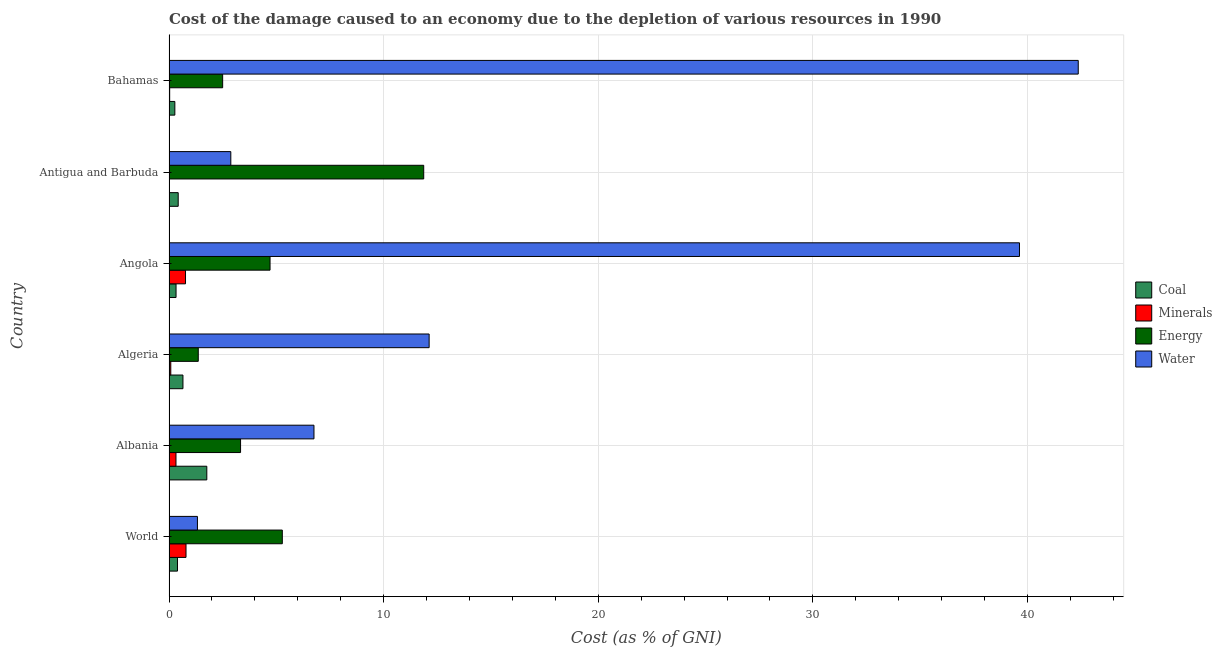How many different coloured bars are there?
Provide a short and direct response. 4. Are the number of bars per tick equal to the number of legend labels?
Keep it short and to the point. Yes. How many bars are there on the 5th tick from the bottom?
Provide a succinct answer. 4. What is the label of the 1st group of bars from the top?
Make the answer very short. Bahamas. In how many cases, is the number of bars for a given country not equal to the number of legend labels?
Give a very brief answer. 0. What is the cost of damage due to depletion of coal in World?
Make the answer very short. 0.4. Across all countries, what is the maximum cost of damage due to depletion of energy?
Offer a terse response. 11.87. Across all countries, what is the minimum cost of damage due to depletion of water?
Provide a succinct answer. 1.32. In which country was the cost of damage due to depletion of water minimum?
Offer a terse response. World. What is the total cost of damage due to depletion of water in the graph?
Offer a terse response. 105.07. What is the difference between the cost of damage due to depletion of energy in Albania and that in Bahamas?
Keep it short and to the point. 0.83. What is the difference between the cost of damage due to depletion of energy in Angola and the cost of damage due to depletion of minerals in Antigua and Barbuda?
Your answer should be very brief. 4.69. What is the average cost of damage due to depletion of coal per country?
Your answer should be compact. 0.64. What is the difference between the cost of damage due to depletion of coal and cost of damage due to depletion of energy in Bahamas?
Give a very brief answer. -2.23. In how many countries, is the cost of damage due to depletion of minerals greater than 40 %?
Your answer should be compact. 0. What is the ratio of the cost of damage due to depletion of coal in Albania to that in Algeria?
Your answer should be very brief. 2.71. Is the difference between the cost of damage due to depletion of coal in Albania and Bahamas greater than the difference between the cost of damage due to depletion of energy in Albania and Bahamas?
Offer a very short reply. Yes. What is the difference between the highest and the second highest cost of damage due to depletion of energy?
Keep it short and to the point. 6.59. What is the difference between the highest and the lowest cost of damage due to depletion of coal?
Make the answer very short. 1.49. In how many countries, is the cost of damage due to depletion of minerals greater than the average cost of damage due to depletion of minerals taken over all countries?
Provide a short and direct response. 2. Is it the case that in every country, the sum of the cost of damage due to depletion of coal and cost of damage due to depletion of water is greater than the sum of cost of damage due to depletion of energy and cost of damage due to depletion of minerals?
Make the answer very short. No. What does the 3rd bar from the top in World represents?
Ensure brevity in your answer.  Minerals. What does the 4th bar from the bottom in Algeria represents?
Ensure brevity in your answer.  Water. Is it the case that in every country, the sum of the cost of damage due to depletion of coal and cost of damage due to depletion of minerals is greater than the cost of damage due to depletion of energy?
Ensure brevity in your answer.  No. How many countries are there in the graph?
Give a very brief answer. 6. What is the difference between two consecutive major ticks on the X-axis?
Keep it short and to the point. 10. Does the graph contain any zero values?
Offer a very short reply. No. Does the graph contain grids?
Provide a short and direct response. Yes. How are the legend labels stacked?
Your response must be concise. Vertical. What is the title of the graph?
Keep it short and to the point. Cost of the damage caused to an economy due to the depletion of various resources in 1990 . Does "Miscellaneous expenses" appear as one of the legend labels in the graph?
Offer a terse response. No. What is the label or title of the X-axis?
Your answer should be very brief. Cost (as % of GNI). What is the label or title of the Y-axis?
Your answer should be very brief. Country. What is the Cost (as % of GNI) in Coal in World?
Provide a short and direct response. 0.4. What is the Cost (as % of GNI) in Minerals in World?
Ensure brevity in your answer.  0.79. What is the Cost (as % of GNI) in Energy in World?
Your response must be concise. 5.28. What is the Cost (as % of GNI) of Water in World?
Provide a succinct answer. 1.32. What is the Cost (as % of GNI) in Coal in Albania?
Offer a very short reply. 1.76. What is the Cost (as % of GNI) of Minerals in Albania?
Offer a terse response. 0.33. What is the Cost (as % of GNI) in Energy in Albania?
Give a very brief answer. 3.33. What is the Cost (as % of GNI) in Water in Albania?
Offer a terse response. 6.75. What is the Cost (as % of GNI) of Coal in Algeria?
Offer a very short reply. 0.65. What is the Cost (as % of GNI) in Minerals in Algeria?
Offer a very short reply. 0.08. What is the Cost (as % of GNI) in Energy in Algeria?
Provide a succinct answer. 1.36. What is the Cost (as % of GNI) in Water in Algeria?
Your answer should be very brief. 12.12. What is the Cost (as % of GNI) of Coal in Angola?
Offer a terse response. 0.33. What is the Cost (as % of GNI) in Minerals in Angola?
Make the answer very short. 0.77. What is the Cost (as % of GNI) of Energy in Angola?
Provide a short and direct response. 4.71. What is the Cost (as % of GNI) of Water in Angola?
Make the answer very short. 39.63. What is the Cost (as % of GNI) of Coal in Antigua and Barbuda?
Your answer should be compact. 0.43. What is the Cost (as % of GNI) in Minerals in Antigua and Barbuda?
Your response must be concise. 0.02. What is the Cost (as % of GNI) of Energy in Antigua and Barbuda?
Your answer should be compact. 11.87. What is the Cost (as % of GNI) of Water in Antigua and Barbuda?
Keep it short and to the point. 2.88. What is the Cost (as % of GNI) in Coal in Bahamas?
Keep it short and to the point. 0.27. What is the Cost (as % of GNI) of Minerals in Bahamas?
Offer a very short reply. 0.03. What is the Cost (as % of GNI) in Energy in Bahamas?
Your answer should be compact. 2.5. What is the Cost (as % of GNI) of Water in Bahamas?
Make the answer very short. 42.36. Across all countries, what is the maximum Cost (as % of GNI) of Coal?
Provide a succinct answer. 1.76. Across all countries, what is the maximum Cost (as % of GNI) in Minerals?
Your answer should be compact. 0.79. Across all countries, what is the maximum Cost (as % of GNI) in Energy?
Keep it short and to the point. 11.87. Across all countries, what is the maximum Cost (as % of GNI) in Water?
Offer a terse response. 42.36. Across all countries, what is the minimum Cost (as % of GNI) in Coal?
Your answer should be compact. 0.27. Across all countries, what is the minimum Cost (as % of GNI) of Minerals?
Your response must be concise. 0.02. Across all countries, what is the minimum Cost (as % of GNI) of Energy?
Give a very brief answer. 1.36. Across all countries, what is the minimum Cost (as % of GNI) of Water?
Provide a short and direct response. 1.32. What is the total Cost (as % of GNI) in Coal in the graph?
Ensure brevity in your answer.  3.84. What is the total Cost (as % of GNI) of Minerals in the graph?
Offer a very short reply. 2.02. What is the total Cost (as % of GNI) of Energy in the graph?
Your response must be concise. 29.05. What is the total Cost (as % of GNI) of Water in the graph?
Provide a short and direct response. 105.07. What is the difference between the Cost (as % of GNI) of Coal in World and that in Albania?
Make the answer very short. -1.37. What is the difference between the Cost (as % of GNI) of Minerals in World and that in Albania?
Keep it short and to the point. 0.47. What is the difference between the Cost (as % of GNI) of Energy in World and that in Albania?
Provide a succinct answer. 1.94. What is the difference between the Cost (as % of GNI) in Water in World and that in Albania?
Make the answer very short. -5.43. What is the difference between the Cost (as % of GNI) in Coal in World and that in Algeria?
Your answer should be compact. -0.26. What is the difference between the Cost (as % of GNI) in Minerals in World and that in Algeria?
Your answer should be very brief. 0.71. What is the difference between the Cost (as % of GNI) of Energy in World and that in Algeria?
Give a very brief answer. 3.92. What is the difference between the Cost (as % of GNI) in Water in World and that in Algeria?
Offer a terse response. -10.8. What is the difference between the Cost (as % of GNI) in Coal in World and that in Angola?
Your response must be concise. 0.07. What is the difference between the Cost (as % of GNI) of Minerals in World and that in Angola?
Your answer should be very brief. 0.02. What is the difference between the Cost (as % of GNI) in Energy in World and that in Angola?
Offer a very short reply. 0.57. What is the difference between the Cost (as % of GNI) in Water in World and that in Angola?
Ensure brevity in your answer.  -38.3. What is the difference between the Cost (as % of GNI) in Coal in World and that in Antigua and Barbuda?
Ensure brevity in your answer.  -0.03. What is the difference between the Cost (as % of GNI) in Minerals in World and that in Antigua and Barbuda?
Provide a succinct answer. 0.77. What is the difference between the Cost (as % of GNI) of Energy in World and that in Antigua and Barbuda?
Your response must be concise. -6.59. What is the difference between the Cost (as % of GNI) in Water in World and that in Antigua and Barbuda?
Your answer should be compact. -1.56. What is the difference between the Cost (as % of GNI) of Coal in World and that in Bahamas?
Ensure brevity in your answer.  0.12. What is the difference between the Cost (as % of GNI) in Minerals in World and that in Bahamas?
Keep it short and to the point. 0.76. What is the difference between the Cost (as % of GNI) in Energy in World and that in Bahamas?
Offer a very short reply. 2.78. What is the difference between the Cost (as % of GNI) of Water in World and that in Bahamas?
Provide a succinct answer. -41.04. What is the difference between the Cost (as % of GNI) of Coal in Albania and that in Algeria?
Keep it short and to the point. 1.11. What is the difference between the Cost (as % of GNI) in Minerals in Albania and that in Algeria?
Give a very brief answer. 0.24. What is the difference between the Cost (as % of GNI) of Energy in Albania and that in Algeria?
Ensure brevity in your answer.  1.97. What is the difference between the Cost (as % of GNI) in Water in Albania and that in Algeria?
Your answer should be compact. -5.37. What is the difference between the Cost (as % of GNI) of Coal in Albania and that in Angola?
Make the answer very short. 1.43. What is the difference between the Cost (as % of GNI) of Minerals in Albania and that in Angola?
Your answer should be compact. -0.44. What is the difference between the Cost (as % of GNI) of Energy in Albania and that in Angola?
Give a very brief answer. -1.37. What is the difference between the Cost (as % of GNI) in Water in Albania and that in Angola?
Your answer should be compact. -32.87. What is the difference between the Cost (as % of GNI) of Coal in Albania and that in Antigua and Barbuda?
Offer a very short reply. 1.33. What is the difference between the Cost (as % of GNI) of Minerals in Albania and that in Antigua and Barbuda?
Give a very brief answer. 0.3. What is the difference between the Cost (as % of GNI) of Energy in Albania and that in Antigua and Barbuda?
Your answer should be very brief. -8.53. What is the difference between the Cost (as % of GNI) in Water in Albania and that in Antigua and Barbuda?
Offer a very short reply. 3.87. What is the difference between the Cost (as % of GNI) in Coal in Albania and that in Bahamas?
Make the answer very short. 1.49. What is the difference between the Cost (as % of GNI) of Minerals in Albania and that in Bahamas?
Provide a succinct answer. 0.29. What is the difference between the Cost (as % of GNI) of Energy in Albania and that in Bahamas?
Provide a short and direct response. 0.83. What is the difference between the Cost (as % of GNI) of Water in Albania and that in Bahamas?
Keep it short and to the point. -35.61. What is the difference between the Cost (as % of GNI) in Coal in Algeria and that in Angola?
Make the answer very short. 0.32. What is the difference between the Cost (as % of GNI) in Minerals in Algeria and that in Angola?
Your response must be concise. -0.69. What is the difference between the Cost (as % of GNI) in Energy in Algeria and that in Angola?
Your answer should be compact. -3.34. What is the difference between the Cost (as % of GNI) of Water in Algeria and that in Angola?
Ensure brevity in your answer.  -27.51. What is the difference between the Cost (as % of GNI) in Coal in Algeria and that in Antigua and Barbuda?
Keep it short and to the point. 0.22. What is the difference between the Cost (as % of GNI) of Minerals in Algeria and that in Antigua and Barbuda?
Give a very brief answer. 0.06. What is the difference between the Cost (as % of GNI) in Energy in Algeria and that in Antigua and Barbuda?
Your answer should be compact. -10.5. What is the difference between the Cost (as % of GNI) in Water in Algeria and that in Antigua and Barbuda?
Provide a short and direct response. 9.24. What is the difference between the Cost (as % of GNI) in Coal in Algeria and that in Bahamas?
Make the answer very short. 0.38. What is the difference between the Cost (as % of GNI) of Minerals in Algeria and that in Bahamas?
Ensure brevity in your answer.  0.05. What is the difference between the Cost (as % of GNI) of Energy in Algeria and that in Bahamas?
Give a very brief answer. -1.14. What is the difference between the Cost (as % of GNI) in Water in Algeria and that in Bahamas?
Give a very brief answer. -30.24. What is the difference between the Cost (as % of GNI) of Coal in Angola and that in Antigua and Barbuda?
Provide a short and direct response. -0.1. What is the difference between the Cost (as % of GNI) in Minerals in Angola and that in Antigua and Barbuda?
Your answer should be very brief. 0.75. What is the difference between the Cost (as % of GNI) of Energy in Angola and that in Antigua and Barbuda?
Offer a very short reply. -7.16. What is the difference between the Cost (as % of GNI) of Water in Angola and that in Antigua and Barbuda?
Your answer should be compact. 36.75. What is the difference between the Cost (as % of GNI) of Coal in Angola and that in Bahamas?
Your response must be concise. 0.06. What is the difference between the Cost (as % of GNI) of Minerals in Angola and that in Bahamas?
Offer a very short reply. 0.74. What is the difference between the Cost (as % of GNI) of Energy in Angola and that in Bahamas?
Your response must be concise. 2.21. What is the difference between the Cost (as % of GNI) of Water in Angola and that in Bahamas?
Make the answer very short. -2.74. What is the difference between the Cost (as % of GNI) of Coal in Antigua and Barbuda and that in Bahamas?
Make the answer very short. 0.16. What is the difference between the Cost (as % of GNI) in Minerals in Antigua and Barbuda and that in Bahamas?
Ensure brevity in your answer.  -0.01. What is the difference between the Cost (as % of GNI) of Energy in Antigua and Barbuda and that in Bahamas?
Your response must be concise. 9.37. What is the difference between the Cost (as % of GNI) of Water in Antigua and Barbuda and that in Bahamas?
Make the answer very short. -39.48. What is the difference between the Cost (as % of GNI) of Coal in World and the Cost (as % of GNI) of Minerals in Albania?
Give a very brief answer. 0.07. What is the difference between the Cost (as % of GNI) in Coal in World and the Cost (as % of GNI) in Energy in Albania?
Make the answer very short. -2.94. What is the difference between the Cost (as % of GNI) in Coal in World and the Cost (as % of GNI) in Water in Albania?
Your response must be concise. -6.36. What is the difference between the Cost (as % of GNI) of Minerals in World and the Cost (as % of GNI) of Energy in Albania?
Your answer should be very brief. -2.54. What is the difference between the Cost (as % of GNI) in Minerals in World and the Cost (as % of GNI) in Water in Albania?
Your answer should be compact. -5.96. What is the difference between the Cost (as % of GNI) of Energy in World and the Cost (as % of GNI) of Water in Albania?
Give a very brief answer. -1.47. What is the difference between the Cost (as % of GNI) of Coal in World and the Cost (as % of GNI) of Minerals in Algeria?
Your answer should be very brief. 0.31. What is the difference between the Cost (as % of GNI) in Coal in World and the Cost (as % of GNI) in Energy in Algeria?
Your answer should be compact. -0.97. What is the difference between the Cost (as % of GNI) of Coal in World and the Cost (as % of GNI) of Water in Algeria?
Your answer should be compact. -11.73. What is the difference between the Cost (as % of GNI) of Minerals in World and the Cost (as % of GNI) of Energy in Algeria?
Ensure brevity in your answer.  -0.57. What is the difference between the Cost (as % of GNI) of Minerals in World and the Cost (as % of GNI) of Water in Algeria?
Your answer should be very brief. -11.33. What is the difference between the Cost (as % of GNI) in Energy in World and the Cost (as % of GNI) in Water in Algeria?
Your answer should be compact. -6.84. What is the difference between the Cost (as % of GNI) of Coal in World and the Cost (as % of GNI) of Minerals in Angola?
Make the answer very short. -0.37. What is the difference between the Cost (as % of GNI) of Coal in World and the Cost (as % of GNI) of Energy in Angola?
Your answer should be very brief. -4.31. What is the difference between the Cost (as % of GNI) of Coal in World and the Cost (as % of GNI) of Water in Angola?
Give a very brief answer. -39.23. What is the difference between the Cost (as % of GNI) in Minerals in World and the Cost (as % of GNI) in Energy in Angola?
Your response must be concise. -3.92. What is the difference between the Cost (as % of GNI) in Minerals in World and the Cost (as % of GNI) in Water in Angola?
Ensure brevity in your answer.  -38.83. What is the difference between the Cost (as % of GNI) of Energy in World and the Cost (as % of GNI) of Water in Angola?
Provide a short and direct response. -34.35. What is the difference between the Cost (as % of GNI) in Coal in World and the Cost (as % of GNI) in Minerals in Antigua and Barbuda?
Make the answer very short. 0.37. What is the difference between the Cost (as % of GNI) in Coal in World and the Cost (as % of GNI) in Energy in Antigua and Barbuda?
Keep it short and to the point. -11.47. What is the difference between the Cost (as % of GNI) of Coal in World and the Cost (as % of GNI) of Water in Antigua and Barbuda?
Make the answer very short. -2.49. What is the difference between the Cost (as % of GNI) of Minerals in World and the Cost (as % of GNI) of Energy in Antigua and Barbuda?
Keep it short and to the point. -11.08. What is the difference between the Cost (as % of GNI) in Minerals in World and the Cost (as % of GNI) in Water in Antigua and Barbuda?
Your answer should be compact. -2.09. What is the difference between the Cost (as % of GNI) in Energy in World and the Cost (as % of GNI) in Water in Antigua and Barbuda?
Your answer should be compact. 2.4. What is the difference between the Cost (as % of GNI) in Coal in World and the Cost (as % of GNI) in Minerals in Bahamas?
Keep it short and to the point. 0.36. What is the difference between the Cost (as % of GNI) of Coal in World and the Cost (as % of GNI) of Energy in Bahamas?
Give a very brief answer. -2.1. What is the difference between the Cost (as % of GNI) of Coal in World and the Cost (as % of GNI) of Water in Bahamas?
Offer a terse response. -41.97. What is the difference between the Cost (as % of GNI) in Minerals in World and the Cost (as % of GNI) in Energy in Bahamas?
Ensure brevity in your answer.  -1.71. What is the difference between the Cost (as % of GNI) in Minerals in World and the Cost (as % of GNI) in Water in Bahamas?
Provide a succinct answer. -41.57. What is the difference between the Cost (as % of GNI) of Energy in World and the Cost (as % of GNI) of Water in Bahamas?
Provide a succinct answer. -37.09. What is the difference between the Cost (as % of GNI) in Coal in Albania and the Cost (as % of GNI) in Minerals in Algeria?
Your response must be concise. 1.68. What is the difference between the Cost (as % of GNI) of Coal in Albania and the Cost (as % of GNI) of Energy in Algeria?
Your response must be concise. 0.4. What is the difference between the Cost (as % of GNI) in Coal in Albania and the Cost (as % of GNI) in Water in Algeria?
Provide a succinct answer. -10.36. What is the difference between the Cost (as % of GNI) of Minerals in Albania and the Cost (as % of GNI) of Energy in Algeria?
Provide a short and direct response. -1.04. What is the difference between the Cost (as % of GNI) of Minerals in Albania and the Cost (as % of GNI) of Water in Algeria?
Offer a terse response. -11.79. What is the difference between the Cost (as % of GNI) in Energy in Albania and the Cost (as % of GNI) in Water in Algeria?
Ensure brevity in your answer.  -8.79. What is the difference between the Cost (as % of GNI) of Coal in Albania and the Cost (as % of GNI) of Minerals in Angola?
Offer a very short reply. 0.99. What is the difference between the Cost (as % of GNI) in Coal in Albania and the Cost (as % of GNI) in Energy in Angola?
Ensure brevity in your answer.  -2.95. What is the difference between the Cost (as % of GNI) in Coal in Albania and the Cost (as % of GNI) in Water in Angola?
Provide a short and direct response. -37.86. What is the difference between the Cost (as % of GNI) in Minerals in Albania and the Cost (as % of GNI) in Energy in Angola?
Your response must be concise. -4.38. What is the difference between the Cost (as % of GNI) of Minerals in Albania and the Cost (as % of GNI) of Water in Angola?
Your answer should be very brief. -39.3. What is the difference between the Cost (as % of GNI) in Energy in Albania and the Cost (as % of GNI) in Water in Angola?
Your response must be concise. -36.29. What is the difference between the Cost (as % of GNI) in Coal in Albania and the Cost (as % of GNI) in Minerals in Antigua and Barbuda?
Give a very brief answer. 1.74. What is the difference between the Cost (as % of GNI) of Coal in Albania and the Cost (as % of GNI) of Energy in Antigua and Barbuda?
Keep it short and to the point. -10.11. What is the difference between the Cost (as % of GNI) of Coal in Albania and the Cost (as % of GNI) of Water in Antigua and Barbuda?
Ensure brevity in your answer.  -1.12. What is the difference between the Cost (as % of GNI) in Minerals in Albania and the Cost (as % of GNI) in Energy in Antigua and Barbuda?
Your response must be concise. -11.54. What is the difference between the Cost (as % of GNI) of Minerals in Albania and the Cost (as % of GNI) of Water in Antigua and Barbuda?
Your response must be concise. -2.55. What is the difference between the Cost (as % of GNI) in Energy in Albania and the Cost (as % of GNI) in Water in Antigua and Barbuda?
Provide a succinct answer. 0.45. What is the difference between the Cost (as % of GNI) of Coal in Albania and the Cost (as % of GNI) of Minerals in Bahamas?
Give a very brief answer. 1.73. What is the difference between the Cost (as % of GNI) in Coal in Albania and the Cost (as % of GNI) in Energy in Bahamas?
Your response must be concise. -0.74. What is the difference between the Cost (as % of GNI) in Coal in Albania and the Cost (as % of GNI) in Water in Bahamas?
Provide a short and direct response. -40.6. What is the difference between the Cost (as % of GNI) of Minerals in Albania and the Cost (as % of GNI) of Energy in Bahamas?
Your answer should be very brief. -2.17. What is the difference between the Cost (as % of GNI) in Minerals in Albania and the Cost (as % of GNI) in Water in Bahamas?
Make the answer very short. -42.04. What is the difference between the Cost (as % of GNI) in Energy in Albania and the Cost (as % of GNI) in Water in Bahamas?
Offer a terse response. -39.03. What is the difference between the Cost (as % of GNI) in Coal in Algeria and the Cost (as % of GNI) in Minerals in Angola?
Your answer should be compact. -0.12. What is the difference between the Cost (as % of GNI) of Coal in Algeria and the Cost (as % of GNI) of Energy in Angola?
Offer a very short reply. -4.06. What is the difference between the Cost (as % of GNI) in Coal in Algeria and the Cost (as % of GNI) in Water in Angola?
Your answer should be compact. -38.98. What is the difference between the Cost (as % of GNI) of Minerals in Algeria and the Cost (as % of GNI) of Energy in Angola?
Provide a short and direct response. -4.63. What is the difference between the Cost (as % of GNI) of Minerals in Algeria and the Cost (as % of GNI) of Water in Angola?
Your answer should be very brief. -39.54. What is the difference between the Cost (as % of GNI) of Energy in Algeria and the Cost (as % of GNI) of Water in Angola?
Offer a very short reply. -38.26. What is the difference between the Cost (as % of GNI) in Coal in Algeria and the Cost (as % of GNI) in Minerals in Antigua and Barbuda?
Keep it short and to the point. 0.63. What is the difference between the Cost (as % of GNI) of Coal in Algeria and the Cost (as % of GNI) of Energy in Antigua and Barbuda?
Your answer should be compact. -11.22. What is the difference between the Cost (as % of GNI) in Coal in Algeria and the Cost (as % of GNI) in Water in Antigua and Barbuda?
Your answer should be very brief. -2.23. What is the difference between the Cost (as % of GNI) in Minerals in Algeria and the Cost (as % of GNI) in Energy in Antigua and Barbuda?
Ensure brevity in your answer.  -11.79. What is the difference between the Cost (as % of GNI) in Minerals in Algeria and the Cost (as % of GNI) in Water in Antigua and Barbuda?
Offer a very short reply. -2.8. What is the difference between the Cost (as % of GNI) in Energy in Algeria and the Cost (as % of GNI) in Water in Antigua and Barbuda?
Provide a succinct answer. -1.52. What is the difference between the Cost (as % of GNI) in Coal in Algeria and the Cost (as % of GNI) in Minerals in Bahamas?
Offer a terse response. 0.62. What is the difference between the Cost (as % of GNI) of Coal in Algeria and the Cost (as % of GNI) of Energy in Bahamas?
Make the answer very short. -1.85. What is the difference between the Cost (as % of GNI) of Coal in Algeria and the Cost (as % of GNI) of Water in Bahamas?
Your answer should be very brief. -41.71. What is the difference between the Cost (as % of GNI) in Minerals in Algeria and the Cost (as % of GNI) in Energy in Bahamas?
Keep it short and to the point. -2.42. What is the difference between the Cost (as % of GNI) in Minerals in Algeria and the Cost (as % of GNI) in Water in Bahamas?
Provide a short and direct response. -42.28. What is the difference between the Cost (as % of GNI) in Energy in Algeria and the Cost (as % of GNI) in Water in Bahamas?
Provide a short and direct response. -41. What is the difference between the Cost (as % of GNI) in Coal in Angola and the Cost (as % of GNI) in Minerals in Antigua and Barbuda?
Give a very brief answer. 0.31. What is the difference between the Cost (as % of GNI) in Coal in Angola and the Cost (as % of GNI) in Energy in Antigua and Barbuda?
Provide a succinct answer. -11.54. What is the difference between the Cost (as % of GNI) of Coal in Angola and the Cost (as % of GNI) of Water in Antigua and Barbuda?
Provide a succinct answer. -2.55. What is the difference between the Cost (as % of GNI) of Minerals in Angola and the Cost (as % of GNI) of Energy in Antigua and Barbuda?
Give a very brief answer. -11.1. What is the difference between the Cost (as % of GNI) in Minerals in Angola and the Cost (as % of GNI) in Water in Antigua and Barbuda?
Your answer should be compact. -2.11. What is the difference between the Cost (as % of GNI) in Energy in Angola and the Cost (as % of GNI) in Water in Antigua and Barbuda?
Ensure brevity in your answer.  1.83. What is the difference between the Cost (as % of GNI) of Coal in Angola and the Cost (as % of GNI) of Minerals in Bahamas?
Make the answer very short. 0.3. What is the difference between the Cost (as % of GNI) in Coal in Angola and the Cost (as % of GNI) in Energy in Bahamas?
Your response must be concise. -2.17. What is the difference between the Cost (as % of GNI) in Coal in Angola and the Cost (as % of GNI) in Water in Bahamas?
Give a very brief answer. -42.04. What is the difference between the Cost (as % of GNI) in Minerals in Angola and the Cost (as % of GNI) in Energy in Bahamas?
Your response must be concise. -1.73. What is the difference between the Cost (as % of GNI) of Minerals in Angola and the Cost (as % of GNI) of Water in Bahamas?
Your answer should be very brief. -41.6. What is the difference between the Cost (as % of GNI) of Energy in Angola and the Cost (as % of GNI) of Water in Bahamas?
Provide a short and direct response. -37.66. What is the difference between the Cost (as % of GNI) of Coal in Antigua and Barbuda and the Cost (as % of GNI) of Minerals in Bahamas?
Make the answer very short. 0.4. What is the difference between the Cost (as % of GNI) of Coal in Antigua and Barbuda and the Cost (as % of GNI) of Energy in Bahamas?
Ensure brevity in your answer.  -2.07. What is the difference between the Cost (as % of GNI) in Coal in Antigua and Barbuda and the Cost (as % of GNI) in Water in Bahamas?
Ensure brevity in your answer.  -41.94. What is the difference between the Cost (as % of GNI) of Minerals in Antigua and Barbuda and the Cost (as % of GNI) of Energy in Bahamas?
Ensure brevity in your answer.  -2.48. What is the difference between the Cost (as % of GNI) in Minerals in Antigua and Barbuda and the Cost (as % of GNI) in Water in Bahamas?
Provide a succinct answer. -42.34. What is the difference between the Cost (as % of GNI) in Energy in Antigua and Barbuda and the Cost (as % of GNI) in Water in Bahamas?
Offer a very short reply. -30.5. What is the average Cost (as % of GNI) in Coal per country?
Your answer should be very brief. 0.64. What is the average Cost (as % of GNI) in Minerals per country?
Offer a very short reply. 0.34. What is the average Cost (as % of GNI) in Energy per country?
Your response must be concise. 4.84. What is the average Cost (as % of GNI) of Water per country?
Provide a short and direct response. 17.51. What is the difference between the Cost (as % of GNI) of Coal and Cost (as % of GNI) of Minerals in World?
Make the answer very short. -0.4. What is the difference between the Cost (as % of GNI) in Coal and Cost (as % of GNI) in Energy in World?
Keep it short and to the point. -4.88. What is the difference between the Cost (as % of GNI) in Coal and Cost (as % of GNI) in Water in World?
Provide a succinct answer. -0.93. What is the difference between the Cost (as % of GNI) in Minerals and Cost (as % of GNI) in Energy in World?
Your response must be concise. -4.49. What is the difference between the Cost (as % of GNI) in Minerals and Cost (as % of GNI) in Water in World?
Your response must be concise. -0.53. What is the difference between the Cost (as % of GNI) of Energy and Cost (as % of GNI) of Water in World?
Provide a short and direct response. 3.95. What is the difference between the Cost (as % of GNI) of Coal and Cost (as % of GNI) of Minerals in Albania?
Provide a succinct answer. 1.44. What is the difference between the Cost (as % of GNI) in Coal and Cost (as % of GNI) in Energy in Albania?
Provide a short and direct response. -1.57. What is the difference between the Cost (as % of GNI) in Coal and Cost (as % of GNI) in Water in Albania?
Offer a terse response. -4.99. What is the difference between the Cost (as % of GNI) in Minerals and Cost (as % of GNI) in Energy in Albania?
Your answer should be very brief. -3.01. What is the difference between the Cost (as % of GNI) in Minerals and Cost (as % of GNI) in Water in Albania?
Offer a terse response. -6.43. What is the difference between the Cost (as % of GNI) of Energy and Cost (as % of GNI) of Water in Albania?
Ensure brevity in your answer.  -3.42. What is the difference between the Cost (as % of GNI) in Coal and Cost (as % of GNI) in Minerals in Algeria?
Offer a terse response. 0.57. What is the difference between the Cost (as % of GNI) of Coal and Cost (as % of GNI) of Energy in Algeria?
Provide a short and direct response. -0.71. What is the difference between the Cost (as % of GNI) in Coal and Cost (as % of GNI) in Water in Algeria?
Give a very brief answer. -11.47. What is the difference between the Cost (as % of GNI) in Minerals and Cost (as % of GNI) in Energy in Algeria?
Make the answer very short. -1.28. What is the difference between the Cost (as % of GNI) in Minerals and Cost (as % of GNI) in Water in Algeria?
Offer a terse response. -12.04. What is the difference between the Cost (as % of GNI) in Energy and Cost (as % of GNI) in Water in Algeria?
Your response must be concise. -10.76. What is the difference between the Cost (as % of GNI) of Coal and Cost (as % of GNI) of Minerals in Angola?
Your answer should be very brief. -0.44. What is the difference between the Cost (as % of GNI) in Coal and Cost (as % of GNI) in Energy in Angola?
Offer a terse response. -4.38. What is the difference between the Cost (as % of GNI) of Coal and Cost (as % of GNI) of Water in Angola?
Provide a succinct answer. -39.3. What is the difference between the Cost (as % of GNI) of Minerals and Cost (as % of GNI) of Energy in Angola?
Your answer should be very brief. -3.94. What is the difference between the Cost (as % of GNI) in Minerals and Cost (as % of GNI) in Water in Angola?
Your answer should be very brief. -38.86. What is the difference between the Cost (as % of GNI) in Energy and Cost (as % of GNI) in Water in Angola?
Your answer should be compact. -34.92. What is the difference between the Cost (as % of GNI) in Coal and Cost (as % of GNI) in Minerals in Antigua and Barbuda?
Your response must be concise. 0.41. What is the difference between the Cost (as % of GNI) in Coal and Cost (as % of GNI) in Energy in Antigua and Barbuda?
Ensure brevity in your answer.  -11.44. What is the difference between the Cost (as % of GNI) of Coal and Cost (as % of GNI) of Water in Antigua and Barbuda?
Offer a terse response. -2.45. What is the difference between the Cost (as % of GNI) of Minerals and Cost (as % of GNI) of Energy in Antigua and Barbuda?
Your answer should be very brief. -11.85. What is the difference between the Cost (as % of GNI) in Minerals and Cost (as % of GNI) in Water in Antigua and Barbuda?
Your answer should be compact. -2.86. What is the difference between the Cost (as % of GNI) in Energy and Cost (as % of GNI) in Water in Antigua and Barbuda?
Your answer should be compact. 8.99. What is the difference between the Cost (as % of GNI) in Coal and Cost (as % of GNI) in Minerals in Bahamas?
Offer a very short reply. 0.24. What is the difference between the Cost (as % of GNI) of Coal and Cost (as % of GNI) of Energy in Bahamas?
Provide a succinct answer. -2.23. What is the difference between the Cost (as % of GNI) of Coal and Cost (as % of GNI) of Water in Bahamas?
Offer a terse response. -42.09. What is the difference between the Cost (as % of GNI) of Minerals and Cost (as % of GNI) of Energy in Bahamas?
Your answer should be very brief. -2.47. What is the difference between the Cost (as % of GNI) of Minerals and Cost (as % of GNI) of Water in Bahamas?
Offer a terse response. -42.33. What is the difference between the Cost (as % of GNI) of Energy and Cost (as % of GNI) of Water in Bahamas?
Offer a very short reply. -39.86. What is the ratio of the Cost (as % of GNI) of Coal in World to that in Albania?
Provide a short and direct response. 0.22. What is the ratio of the Cost (as % of GNI) of Minerals in World to that in Albania?
Your answer should be very brief. 2.44. What is the ratio of the Cost (as % of GNI) in Energy in World to that in Albania?
Provide a succinct answer. 1.58. What is the ratio of the Cost (as % of GNI) in Water in World to that in Albania?
Your response must be concise. 0.2. What is the ratio of the Cost (as % of GNI) in Coal in World to that in Algeria?
Provide a succinct answer. 0.61. What is the ratio of the Cost (as % of GNI) in Minerals in World to that in Algeria?
Give a very brief answer. 9.58. What is the ratio of the Cost (as % of GNI) of Energy in World to that in Algeria?
Offer a very short reply. 3.87. What is the ratio of the Cost (as % of GNI) of Water in World to that in Algeria?
Offer a very short reply. 0.11. What is the ratio of the Cost (as % of GNI) of Coal in World to that in Angola?
Provide a succinct answer. 1.2. What is the ratio of the Cost (as % of GNI) of Minerals in World to that in Angola?
Provide a short and direct response. 1.03. What is the ratio of the Cost (as % of GNI) in Energy in World to that in Angola?
Keep it short and to the point. 1.12. What is the ratio of the Cost (as % of GNI) in Water in World to that in Angola?
Keep it short and to the point. 0.03. What is the ratio of the Cost (as % of GNI) of Coal in World to that in Antigua and Barbuda?
Your answer should be compact. 0.92. What is the ratio of the Cost (as % of GNI) in Minerals in World to that in Antigua and Barbuda?
Provide a succinct answer. 36.95. What is the ratio of the Cost (as % of GNI) of Energy in World to that in Antigua and Barbuda?
Provide a short and direct response. 0.44. What is the ratio of the Cost (as % of GNI) in Water in World to that in Antigua and Barbuda?
Your answer should be compact. 0.46. What is the ratio of the Cost (as % of GNI) of Coal in World to that in Bahamas?
Make the answer very short. 1.45. What is the ratio of the Cost (as % of GNI) in Minerals in World to that in Bahamas?
Offer a terse response. 25.46. What is the ratio of the Cost (as % of GNI) in Energy in World to that in Bahamas?
Offer a very short reply. 2.11. What is the ratio of the Cost (as % of GNI) in Water in World to that in Bahamas?
Provide a succinct answer. 0.03. What is the ratio of the Cost (as % of GNI) in Coal in Albania to that in Algeria?
Your answer should be very brief. 2.71. What is the ratio of the Cost (as % of GNI) in Minerals in Albania to that in Algeria?
Offer a terse response. 3.93. What is the ratio of the Cost (as % of GNI) of Energy in Albania to that in Algeria?
Your answer should be very brief. 2.45. What is the ratio of the Cost (as % of GNI) of Water in Albania to that in Algeria?
Your answer should be compact. 0.56. What is the ratio of the Cost (as % of GNI) in Coal in Albania to that in Angola?
Your answer should be very brief. 5.37. What is the ratio of the Cost (as % of GNI) in Minerals in Albania to that in Angola?
Your response must be concise. 0.42. What is the ratio of the Cost (as % of GNI) of Energy in Albania to that in Angola?
Offer a terse response. 0.71. What is the ratio of the Cost (as % of GNI) of Water in Albania to that in Angola?
Give a very brief answer. 0.17. What is the ratio of the Cost (as % of GNI) in Coal in Albania to that in Antigua and Barbuda?
Ensure brevity in your answer.  4.11. What is the ratio of the Cost (as % of GNI) in Minerals in Albania to that in Antigua and Barbuda?
Offer a very short reply. 15.18. What is the ratio of the Cost (as % of GNI) in Energy in Albania to that in Antigua and Barbuda?
Your answer should be compact. 0.28. What is the ratio of the Cost (as % of GNI) in Water in Albania to that in Antigua and Barbuda?
Keep it short and to the point. 2.35. What is the ratio of the Cost (as % of GNI) in Coal in Albania to that in Bahamas?
Offer a very short reply. 6.48. What is the ratio of the Cost (as % of GNI) in Minerals in Albania to that in Bahamas?
Offer a very short reply. 10.45. What is the ratio of the Cost (as % of GNI) of Energy in Albania to that in Bahamas?
Offer a terse response. 1.33. What is the ratio of the Cost (as % of GNI) in Water in Albania to that in Bahamas?
Your answer should be very brief. 0.16. What is the ratio of the Cost (as % of GNI) of Coal in Algeria to that in Angola?
Your answer should be compact. 1.98. What is the ratio of the Cost (as % of GNI) of Minerals in Algeria to that in Angola?
Give a very brief answer. 0.11. What is the ratio of the Cost (as % of GNI) of Energy in Algeria to that in Angola?
Offer a very short reply. 0.29. What is the ratio of the Cost (as % of GNI) in Water in Algeria to that in Angola?
Your response must be concise. 0.31. What is the ratio of the Cost (as % of GNI) of Coal in Algeria to that in Antigua and Barbuda?
Provide a succinct answer. 1.52. What is the ratio of the Cost (as % of GNI) of Minerals in Algeria to that in Antigua and Barbuda?
Offer a very short reply. 3.86. What is the ratio of the Cost (as % of GNI) of Energy in Algeria to that in Antigua and Barbuda?
Ensure brevity in your answer.  0.11. What is the ratio of the Cost (as % of GNI) in Water in Algeria to that in Antigua and Barbuda?
Your answer should be compact. 4.21. What is the ratio of the Cost (as % of GNI) in Coal in Algeria to that in Bahamas?
Your response must be concise. 2.39. What is the ratio of the Cost (as % of GNI) in Minerals in Algeria to that in Bahamas?
Offer a very short reply. 2.66. What is the ratio of the Cost (as % of GNI) of Energy in Algeria to that in Bahamas?
Your response must be concise. 0.55. What is the ratio of the Cost (as % of GNI) in Water in Algeria to that in Bahamas?
Your answer should be very brief. 0.29. What is the ratio of the Cost (as % of GNI) in Coal in Angola to that in Antigua and Barbuda?
Give a very brief answer. 0.77. What is the ratio of the Cost (as % of GNI) of Minerals in Angola to that in Antigua and Barbuda?
Your answer should be very brief. 35.87. What is the ratio of the Cost (as % of GNI) in Energy in Angola to that in Antigua and Barbuda?
Ensure brevity in your answer.  0.4. What is the ratio of the Cost (as % of GNI) of Water in Angola to that in Antigua and Barbuda?
Provide a short and direct response. 13.76. What is the ratio of the Cost (as % of GNI) in Coal in Angola to that in Bahamas?
Offer a very short reply. 1.21. What is the ratio of the Cost (as % of GNI) of Minerals in Angola to that in Bahamas?
Provide a succinct answer. 24.71. What is the ratio of the Cost (as % of GNI) of Energy in Angola to that in Bahamas?
Your answer should be very brief. 1.88. What is the ratio of the Cost (as % of GNI) of Water in Angola to that in Bahamas?
Ensure brevity in your answer.  0.94. What is the ratio of the Cost (as % of GNI) of Coal in Antigua and Barbuda to that in Bahamas?
Give a very brief answer. 1.58. What is the ratio of the Cost (as % of GNI) of Minerals in Antigua and Barbuda to that in Bahamas?
Provide a succinct answer. 0.69. What is the ratio of the Cost (as % of GNI) in Energy in Antigua and Barbuda to that in Bahamas?
Offer a terse response. 4.75. What is the ratio of the Cost (as % of GNI) of Water in Antigua and Barbuda to that in Bahamas?
Keep it short and to the point. 0.07. What is the difference between the highest and the second highest Cost (as % of GNI) in Coal?
Your answer should be very brief. 1.11. What is the difference between the highest and the second highest Cost (as % of GNI) of Minerals?
Ensure brevity in your answer.  0.02. What is the difference between the highest and the second highest Cost (as % of GNI) of Energy?
Keep it short and to the point. 6.59. What is the difference between the highest and the second highest Cost (as % of GNI) in Water?
Ensure brevity in your answer.  2.74. What is the difference between the highest and the lowest Cost (as % of GNI) of Coal?
Ensure brevity in your answer.  1.49. What is the difference between the highest and the lowest Cost (as % of GNI) in Minerals?
Offer a terse response. 0.77. What is the difference between the highest and the lowest Cost (as % of GNI) of Energy?
Make the answer very short. 10.5. What is the difference between the highest and the lowest Cost (as % of GNI) in Water?
Your response must be concise. 41.04. 